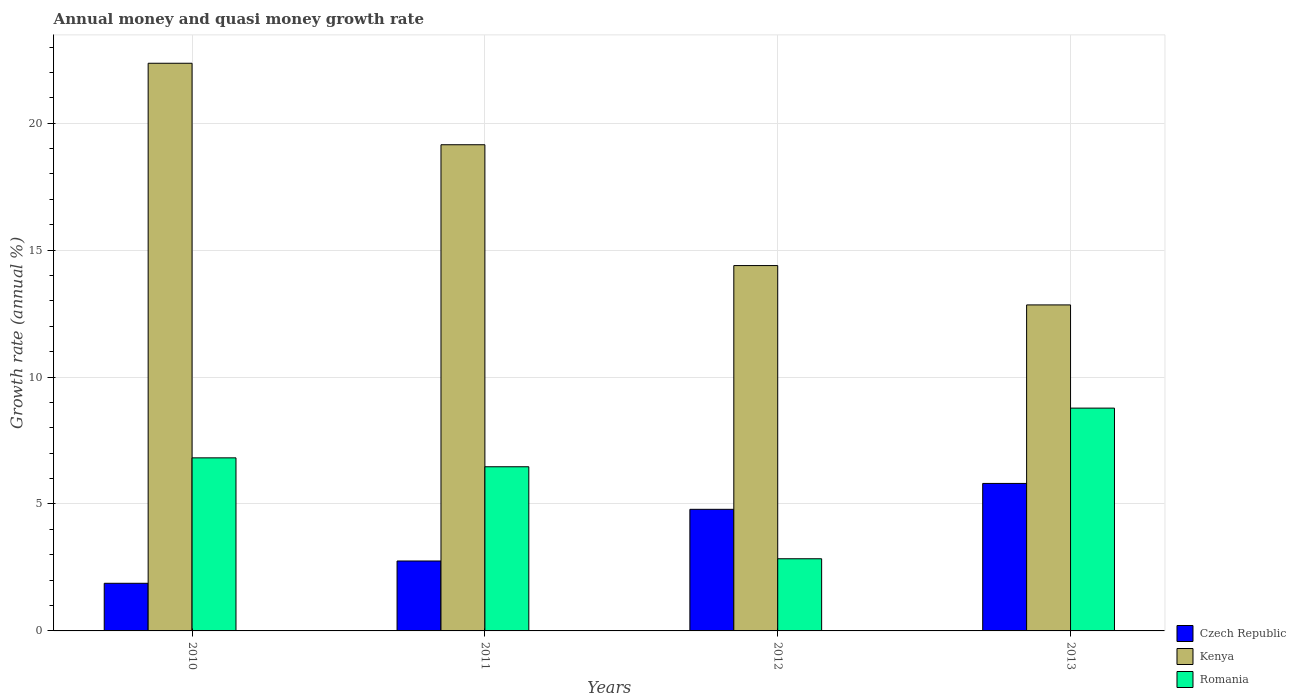How many different coloured bars are there?
Offer a very short reply. 3. How many groups of bars are there?
Your response must be concise. 4. Are the number of bars on each tick of the X-axis equal?
Provide a succinct answer. Yes. In how many cases, is the number of bars for a given year not equal to the number of legend labels?
Give a very brief answer. 0. What is the growth rate in Czech Republic in 2011?
Give a very brief answer. 2.75. Across all years, what is the maximum growth rate in Romania?
Your answer should be very brief. 8.78. Across all years, what is the minimum growth rate in Czech Republic?
Provide a succinct answer. 1.88. In which year was the growth rate in Kenya maximum?
Give a very brief answer. 2010. What is the total growth rate in Romania in the graph?
Your answer should be very brief. 24.9. What is the difference between the growth rate in Romania in 2010 and that in 2012?
Your answer should be compact. 3.97. What is the difference between the growth rate in Czech Republic in 2010 and the growth rate in Kenya in 2013?
Ensure brevity in your answer.  -10.97. What is the average growth rate in Kenya per year?
Make the answer very short. 17.19. In the year 2011, what is the difference between the growth rate in Czech Republic and growth rate in Romania?
Keep it short and to the point. -3.71. In how many years, is the growth rate in Kenya greater than 14 %?
Provide a short and direct response. 3. What is the ratio of the growth rate in Czech Republic in 2011 to that in 2012?
Keep it short and to the point. 0.58. What is the difference between the highest and the second highest growth rate in Czech Republic?
Provide a short and direct response. 1.02. What is the difference between the highest and the lowest growth rate in Kenya?
Give a very brief answer. 9.52. In how many years, is the growth rate in Czech Republic greater than the average growth rate in Czech Republic taken over all years?
Offer a very short reply. 2. What does the 3rd bar from the left in 2011 represents?
Give a very brief answer. Romania. What does the 1st bar from the right in 2013 represents?
Your response must be concise. Romania. Are all the bars in the graph horizontal?
Make the answer very short. No. Does the graph contain any zero values?
Your response must be concise. No. Does the graph contain grids?
Provide a succinct answer. Yes. Where does the legend appear in the graph?
Make the answer very short. Bottom right. How many legend labels are there?
Your answer should be very brief. 3. What is the title of the graph?
Your response must be concise. Annual money and quasi money growth rate. Does "Central African Republic" appear as one of the legend labels in the graph?
Offer a terse response. No. What is the label or title of the Y-axis?
Offer a very short reply. Growth rate (annual %). What is the Growth rate (annual %) in Czech Republic in 2010?
Provide a succinct answer. 1.88. What is the Growth rate (annual %) in Kenya in 2010?
Give a very brief answer. 22.36. What is the Growth rate (annual %) in Romania in 2010?
Offer a very short reply. 6.82. What is the Growth rate (annual %) in Czech Republic in 2011?
Give a very brief answer. 2.75. What is the Growth rate (annual %) in Kenya in 2011?
Your response must be concise. 19.15. What is the Growth rate (annual %) in Romania in 2011?
Your answer should be compact. 6.47. What is the Growth rate (annual %) in Czech Republic in 2012?
Provide a short and direct response. 4.79. What is the Growth rate (annual %) of Kenya in 2012?
Your response must be concise. 14.39. What is the Growth rate (annual %) in Romania in 2012?
Ensure brevity in your answer.  2.84. What is the Growth rate (annual %) in Czech Republic in 2013?
Provide a short and direct response. 5.81. What is the Growth rate (annual %) of Kenya in 2013?
Your answer should be very brief. 12.84. What is the Growth rate (annual %) of Romania in 2013?
Offer a very short reply. 8.78. Across all years, what is the maximum Growth rate (annual %) in Czech Republic?
Keep it short and to the point. 5.81. Across all years, what is the maximum Growth rate (annual %) of Kenya?
Your response must be concise. 22.36. Across all years, what is the maximum Growth rate (annual %) of Romania?
Provide a succinct answer. 8.78. Across all years, what is the minimum Growth rate (annual %) of Czech Republic?
Make the answer very short. 1.88. Across all years, what is the minimum Growth rate (annual %) in Kenya?
Your answer should be very brief. 12.84. Across all years, what is the minimum Growth rate (annual %) of Romania?
Ensure brevity in your answer.  2.84. What is the total Growth rate (annual %) in Czech Republic in the graph?
Your answer should be very brief. 15.23. What is the total Growth rate (annual %) in Kenya in the graph?
Provide a short and direct response. 68.75. What is the total Growth rate (annual %) in Romania in the graph?
Your answer should be very brief. 24.9. What is the difference between the Growth rate (annual %) of Czech Republic in 2010 and that in 2011?
Your answer should be compact. -0.88. What is the difference between the Growth rate (annual %) of Kenya in 2010 and that in 2011?
Ensure brevity in your answer.  3.21. What is the difference between the Growth rate (annual %) of Romania in 2010 and that in 2011?
Keep it short and to the point. 0.35. What is the difference between the Growth rate (annual %) of Czech Republic in 2010 and that in 2012?
Offer a terse response. -2.91. What is the difference between the Growth rate (annual %) of Kenya in 2010 and that in 2012?
Give a very brief answer. 7.97. What is the difference between the Growth rate (annual %) in Romania in 2010 and that in 2012?
Provide a short and direct response. 3.97. What is the difference between the Growth rate (annual %) in Czech Republic in 2010 and that in 2013?
Your answer should be very brief. -3.93. What is the difference between the Growth rate (annual %) in Kenya in 2010 and that in 2013?
Make the answer very short. 9.52. What is the difference between the Growth rate (annual %) in Romania in 2010 and that in 2013?
Provide a succinct answer. -1.96. What is the difference between the Growth rate (annual %) of Czech Republic in 2011 and that in 2012?
Provide a succinct answer. -2.04. What is the difference between the Growth rate (annual %) of Kenya in 2011 and that in 2012?
Make the answer very short. 4.76. What is the difference between the Growth rate (annual %) in Romania in 2011 and that in 2012?
Provide a short and direct response. 3.62. What is the difference between the Growth rate (annual %) in Czech Republic in 2011 and that in 2013?
Provide a short and direct response. -3.06. What is the difference between the Growth rate (annual %) in Kenya in 2011 and that in 2013?
Your answer should be compact. 6.31. What is the difference between the Growth rate (annual %) in Romania in 2011 and that in 2013?
Your response must be concise. -2.31. What is the difference between the Growth rate (annual %) of Czech Republic in 2012 and that in 2013?
Provide a succinct answer. -1.02. What is the difference between the Growth rate (annual %) in Kenya in 2012 and that in 2013?
Offer a terse response. 1.55. What is the difference between the Growth rate (annual %) of Romania in 2012 and that in 2013?
Provide a short and direct response. -5.93. What is the difference between the Growth rate (annual %) in Czech Republic in 2010 and the Growth rate (annual %) in Kenya in 2011?
Keep it short and to the point. -17.28. What is the difference between the Growth rate (annual %) of Czech Republic in 2010 and the Growth rate (annual %) of Romania in 2011?
Offer a very short reply. -4.59. What is the difference between the Growth rate (annual %) in Kenya in 2010 and the Growth rate (annual %) in Romania in 2011?
Your response must be concise. 15.89. What is the difference between the Growth rate (annual %) of Czech Republic in 2010 and the Growth rate (annual %) of Kenya in 2012?
Offer a terse response. -12.52. What is the difference between the Growth rate (annual %) of Czech Republic in 2010 and the Growth rate (annual %) of Romania in 2012?
Your answer should be compact. -0.97. What is the difference between the Growth rate (annual %) in Kenya in 2010 and the Growth rate (annual %) in Romania in 2012?
Offer a terse response. 19.52. What is the difference between the Growth rate (annual %) in Czech Republic in 2010 and the Growth rate (annual %) in Kenya in 2013?
Your answer should be compact. -10.97. What is the difference between the Growth rate (annual %) in Czech Republic in 2010 and the Growth rate (annual %) in Romania in 2013?
Ensure brevity in your answer.  -6.9. What is the difference between the Growth rate (annual %) in Kenya in 2010 and the Growth rate (annual %) in Romania in 2013?
Make the answer very short. 13.58. What is the difference between the Growth rate (annual %) in Czech Republic in 2011 and the Growth rate (annual %) in Kenya in 2012?
Provide a succinct answer. -11.64. What is the difference between the Growth rate (annual %) in Czech Republic in 2011 and the Growth rate (annual %) in Romania in 2012?
Your answer should be compact. -0.09. What is the difference between the Growth rate (annual %) of Kenya in 2011 and the Growth rate (annual %) of Romania in 2012?
Your response must be concise. 16.31. What is the difference between the Growth rate (annual %) in Czech Republic in 2011 and the Growth rate (annual %) in Kenya in 2013?
Your answer should be very brief. -10.09. What is the difference between the Growth rate (annual %) of Czech Republic in 2011 and the Growth rate (annual %) of Romania in 2013?
Make the answer very short. -6.02. What is the difference between the Growth rate (annual %) of Kenya in 2011 and the Growth rate (annual %) of Romania in 2013?
Your answer should be compact. 10.38. What is the difference between the Growth rate (annual %) of Czech Republic in 2012 and the Growth rate (annual %) of Kenya in 2013?
Provide a succinct answer. -8.05. What is the difference between the Growth rate (annual %) in Czech Republic in 2012 and the Growth rate (annual %) in Romania in 2013?
Ensure brevity in your answer.  -3.99. What is the difference between the Growth rate (annual %) of Kenya in 2012 and the Growth rate (annual %) of Romania in 2013?
Provide a short and direct response. 5.62. What is the average Growth rate (annual %) in Czech Republic per year?
Ensure brevity in your answer.  3.81. What is the average Growth rate (annual %) in Kenya per year?
Give a very brief answer. 17.19. What is the average Growth rate (annual %) of Romania per year?
Keep it short and to the point. 6.23. In the year 2010, what is the difference between the Growth rate (annual %) of Czech Republic and Growth rate (annual %) of Kenya?
Give a very brief answer. -20.49. In the year 2010, what is the difference between the Growth rate (annual %) of Czech Republic and Growth rate (annual %) of Romania?
Provide a short and direct response. -4.94. In the year 2010, what is the difference between the Growth rate (annual %) in Kenya and Growth rate (annual %) in Romania?
Offer a very short reply. 15.54. In the year 2011, what is the difference between the Growth rate (annual %) in Czech Republic and Growth rate (annual %) in Kenya?
Your response must be concise. -16.4. In the year 2011, what is the difference between the Growth rate (annual %) in Czech Republic and Growth rate (annual %) in Romania?
Keep it short and to the point. -3.71. In the year 2011, what is the difference between the Growth rate (annual %) of Kenya and Growth rate (annual %) of Romania?
Ensure brevity in your answer.  12.69. In the year 2012, what is the difference between the Growth rate (annual %) of Czech Republic and Growth rate (annual %) of Kenya?
Provide a succinct answer. -9.6. In the year 2012, what is the difference between the Growth rate (annual %) of Czech Republic and Growth rate (annual %) of Romania?
Your response must be concise. 1.95. In the year 2012, what is the difference between the Growth rate (annual %) of Kenya and Growth rate (annual %) of Romania?
Provide a succinct answer. 11.55. In the year 2013, what is the difference between the Growth rate (annual %) of Czech Republic and Growth rate (annual %) of Kenya?
Ensure brevity in your answer.  -7.03. In the year 2013, what is the difference between the Growth rate (annual %) of Czech Republic and Growth rate (annual %) of Romania?
Offer a terse response. -2.97. In the year 2013, what is the difference between the Growth rate (annual %) in Kenya and Growth rate (annual %) in Romania?
Keep it short and to the point. 4.07. What is the ratio of the Growth rate (annual %) in Czech Republic in 2010 to that in 2011?
Provide a succinct answer. 0.68. What is the ratio of the Growth rate (annual %) of Kenya in 2010 to that in 2011?
Offer a very short reply. 1.17. What is the ratio of the Growth rate (annual %) of Romania in 2010 to that in 2011?
Your answer should be compact. 1.05. What is the ratio of the Growth rate (annual %) in Czech Republic in 2010 to that in 2012?
Give a very brief answer. 0.39. What is the ratio of the Growth rate (annual %) in Kenya in 2010 to that in 2012?
Provide a short and direct response. 1.55. What is the ratio of the Growth rate (annual %) of Romania in 2010 to that in 2012?
Your answer should be compact. 2.4. What is the ratio of the Growth rate (annual %) of Czech Republic in 2010 to that in 2013?
Offer a very short reply. 0.32. What is the ratio of the Growth rate (annual %) in Kenya in 2010 to that in 2013?
Your answer should be very brief. 1.74. What is the ratio of the Growth rate (annual %) in Romania in 2010 to that in 2013?
Give a very brief answer. 0.78. What is the ratio of the Growth rate (annual %) in Czech Republic in 2011 to that in 2012?
Offer a very short reply. 0.57. What is the ratio of the Growth rate (annual %) of Kenya in 2011 to that in 2012?
Offer a terse response. 1.33. What is the ratio of the Growth rate (annual %) in Romania in 2011 to that in 2012?
Provide a succinct answer. 2.28. What is the ratio of the Growth rate (annual %) in Czech Republic in 2011 to that in 2013?
Offer a very short reply. 0.47. What is the ratio of the Growth rate (annual %) in Kenya in 2011 to that in 2013?
Your answer should be very brief. 1.49. What is the ratio of the Growth rate (annual %) in Romania in 2011 to that in 2013?
Give a very brief answer. 0.74. What is the ratio of the Growth rate (annual %) in Czech Republic in 2012 to that in 2013?
Your answer should be compact. 0.82. What is the ratio of the Growth rate (annual %) of Kenya in 2012 to that in 2013?
Your response must be concise. 1.12. What is the ratio of the Growth rate (annual %) of Romania in 2012 to that in 2013?
Keep it short and to the point. 0.32. What is the difference between the highest and the second highest Growth rate (annual %) of Czech Republic?
Your response must be concise. 1.02. What is the difference between the highest and the second highest Growth rate (annual %) in Kenya?
Ensure brevity in your answer.  3.21. What is the difference between the highest and the second highest Growth rate (annual %) in Romania?
Provide a short and direct response. 1.96. What is the difference between the highest and the lowest Growth rate (annual %) in Czech Republic?
Offer a terse response. 3.93. What is the difference between the highest and the lowest Growth rate (annual %) in Kenya?
Make the answer very short. 9.52. What is the difference between the highest and the lowest Growth rate (annual %) in Romania?
Your answer should be very brief. 5.93. 